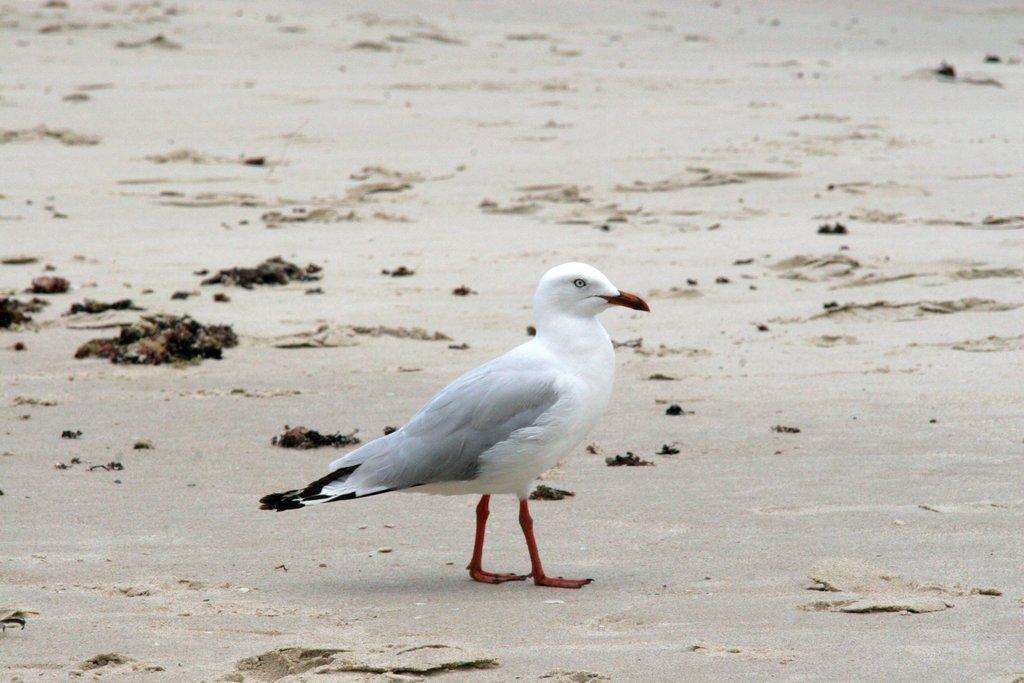Can you describe this image briefly? In this picture I can see a guy standing on the sand. 